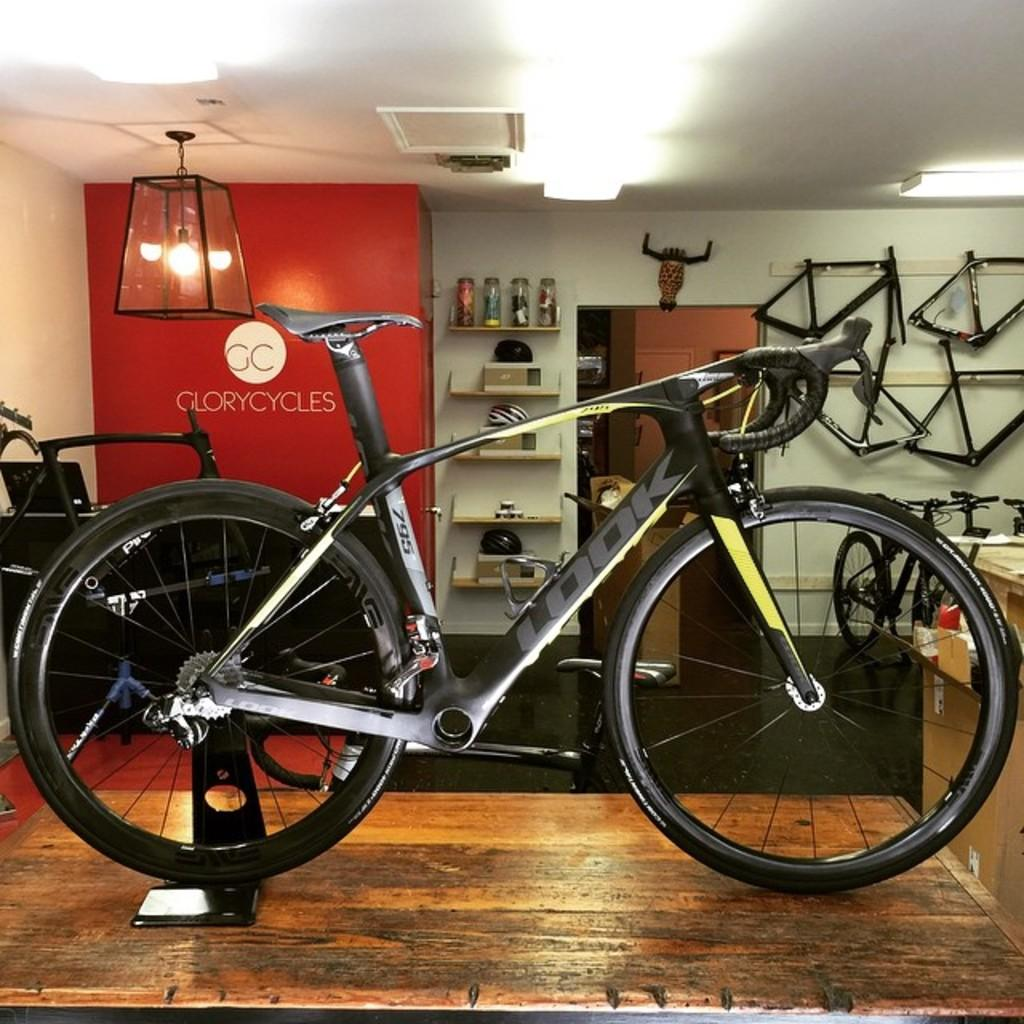What is the main subject of the image? The main subject of the image is a cycle. Can you describe the colors of the cycle? The cycle is off-white, black, and green in color. What can be seen in the background of the image? There is a wall, racks with items, other cycles, cycle parts, and lights visible in the background. What type of body is visible in the image? There is no body present in the image; it features a cycle and various background elements. How many wheels can be seen on the cycle in the image? The image does not show the cycle in a way that allows us to count the number of wheels, but cycles typically have two wheels. 